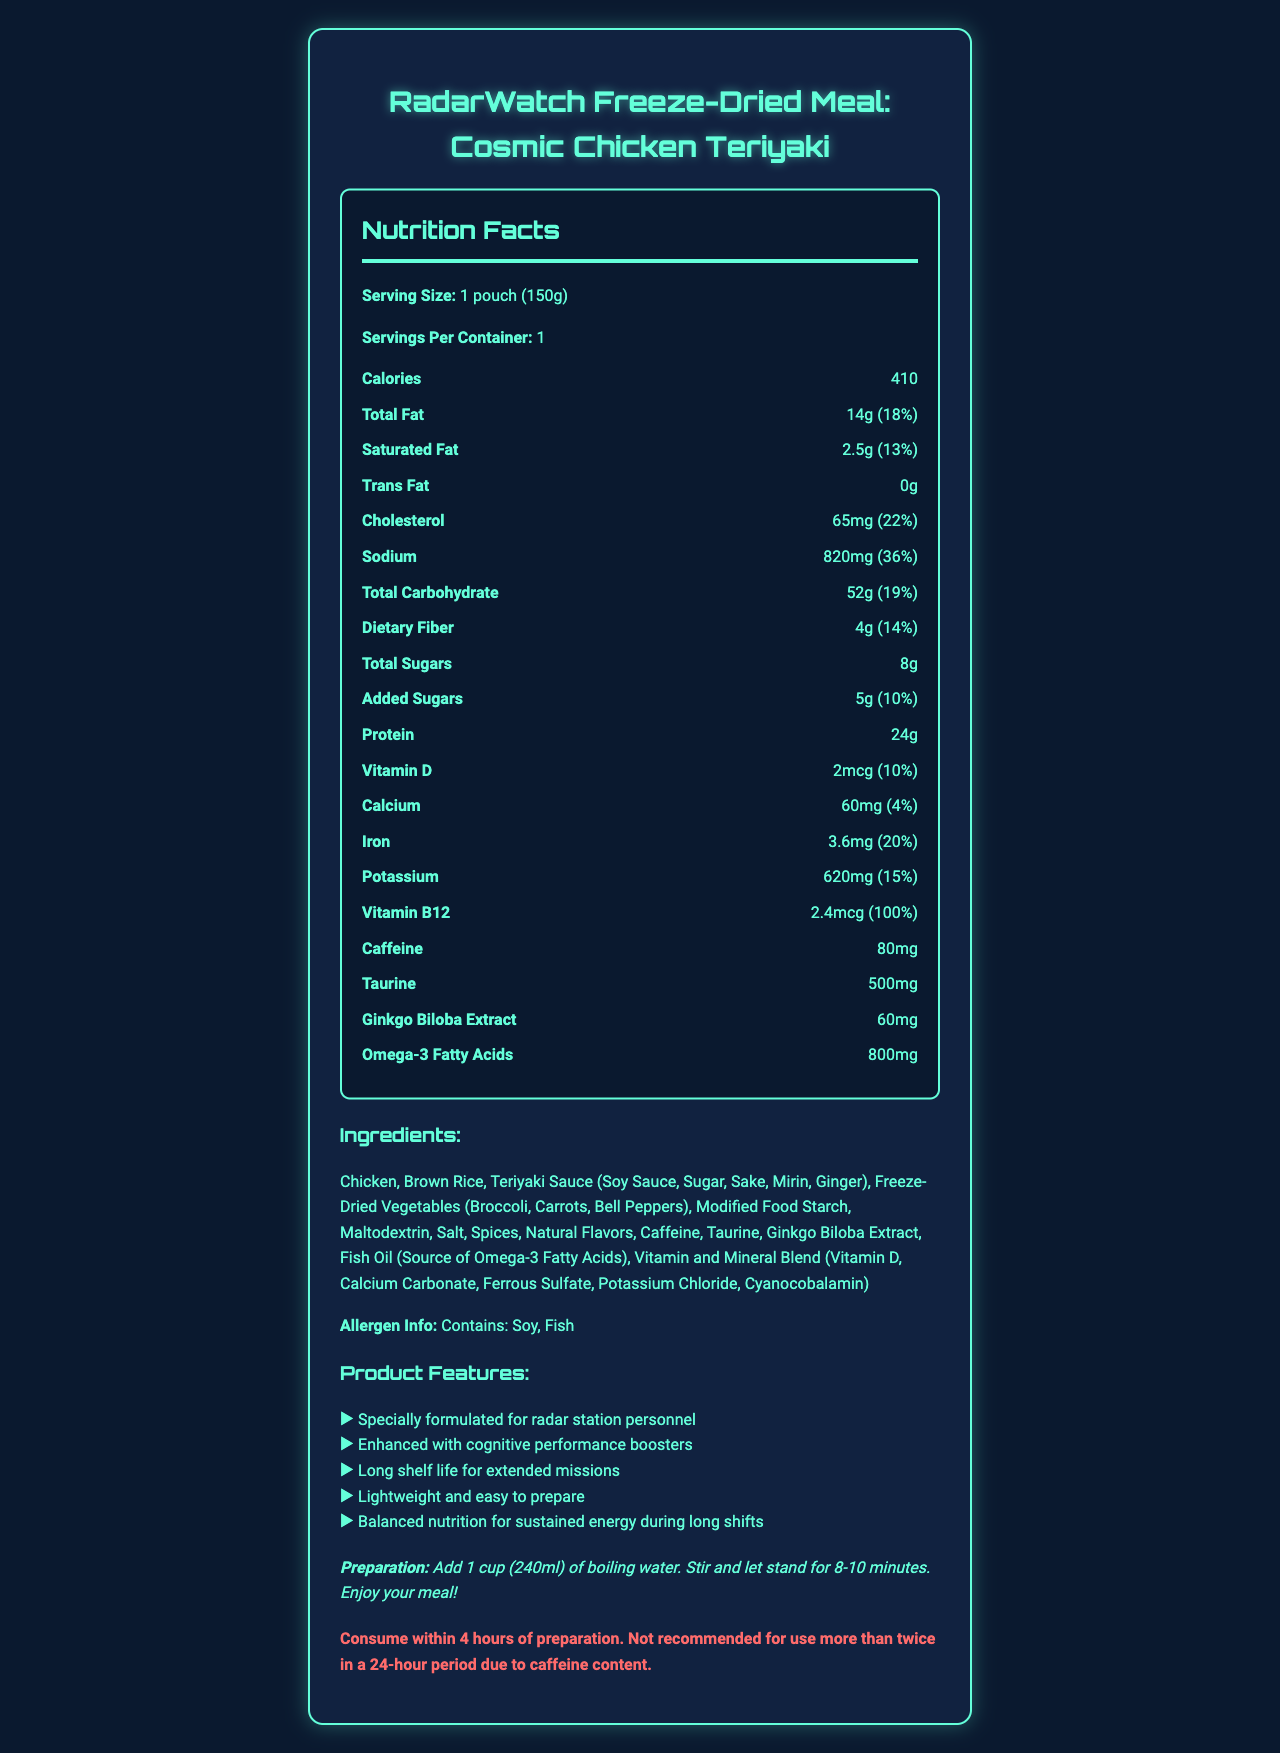What is the serving size of the Cosmic Chicken Teriyaki meal? The serving size is clearly stated as 1 pouch (150g) in the nutrition facts section.
Answer: 1 pouch (150g) How many grams of protein are in one serving? The document specifies that each serving contains 24 grams of protein.
Answer: 24g How much sodium does one pouch contain? The sodium content per serving is listed as 820mg.
Answer: 820mg What is the daily value percentage of saturated fat? The daily value percentage for saturated fat is given as 13%.
Answer: 13% How many calories are in one serving? The number of calories per serving is listed as 410.
Answer: 410 What type of meal is this document describing? A. Freshly prepared meal B. Freeze-dried meal C. Canned meal The product name mentions that it is a "Freeze-Dried Meal."
Answer: B. Freeze-dried meal Which of the following amounts of caffeine does the meal contain? I. 40mg II. 80mg III. 120mg The document states that the meal contains 80mg of caffeine.
Answer: II. 80mg Does the preparation instruction mention using boiling water? The preparation instructions specifically state to add boiling water.
Answer: Yes Is there any trans fat in the Cosmic Chicken Teriyaki meal? The nutrition facts indicate that the trans fat content is 0g.
Answer: No Summarize the main features and nutritional benefits of the Cosmic Chicken Teriyaki meal. The document provides detailed information on the meal's nutrition, ingredients, and features, emphasizing its suitability for radar station personnel.
Answer: The Cosmic Chicken Teriyaki meal is a freeze-dried, specially formulated meal for radar station personnel. It offers balanced nutrition and includes cognitive performance boosters like caffeine, taurine, and ginkgo biloba extract. The meal has 410 calories, 24g of protein, and essential vitamins and minerals for sustained energy during long shifts. It is lightweight, easy to prepare, and has a long shelf life for extended missions. What are the main allergens present in the meal? The allergen info section clearly lists soy and fish as the main allergens.
Answer: Soy, Fish How does the meal enhance cognitive performance? The document mentions that the meal is enhanced with cognitive performance boosters, specifically listing caffeine, taurine, and ginkgo biloba extract.
Answer: Caffeine, Taurine, Ginkgo Biloba Extract What is the recommended maximum number of times this meal should be consumed in a 24-hour period? The usage instructions advise not to consume the meal more than twice in a 24-hour period due to the caffeine content.
Answer: Twice Which ingredient is NOT listed in the document? A. Chicken B. Salt C. Honey D. Modified Food Starch Honey is not mentioned in the list of ingredients.
Answer: C. Honey How long should the meal stand after adding boiling water? The preparation instruction specifies to let the meal stand for 8-10 minutes after adding boiling water.
Answer: 8-10 minutes What is the shelf life of the Cosmic Chicken Teriyaki meal? The document states that the meal has a long shelf life but does not specify the exact duration.
Answer: Not enough information 